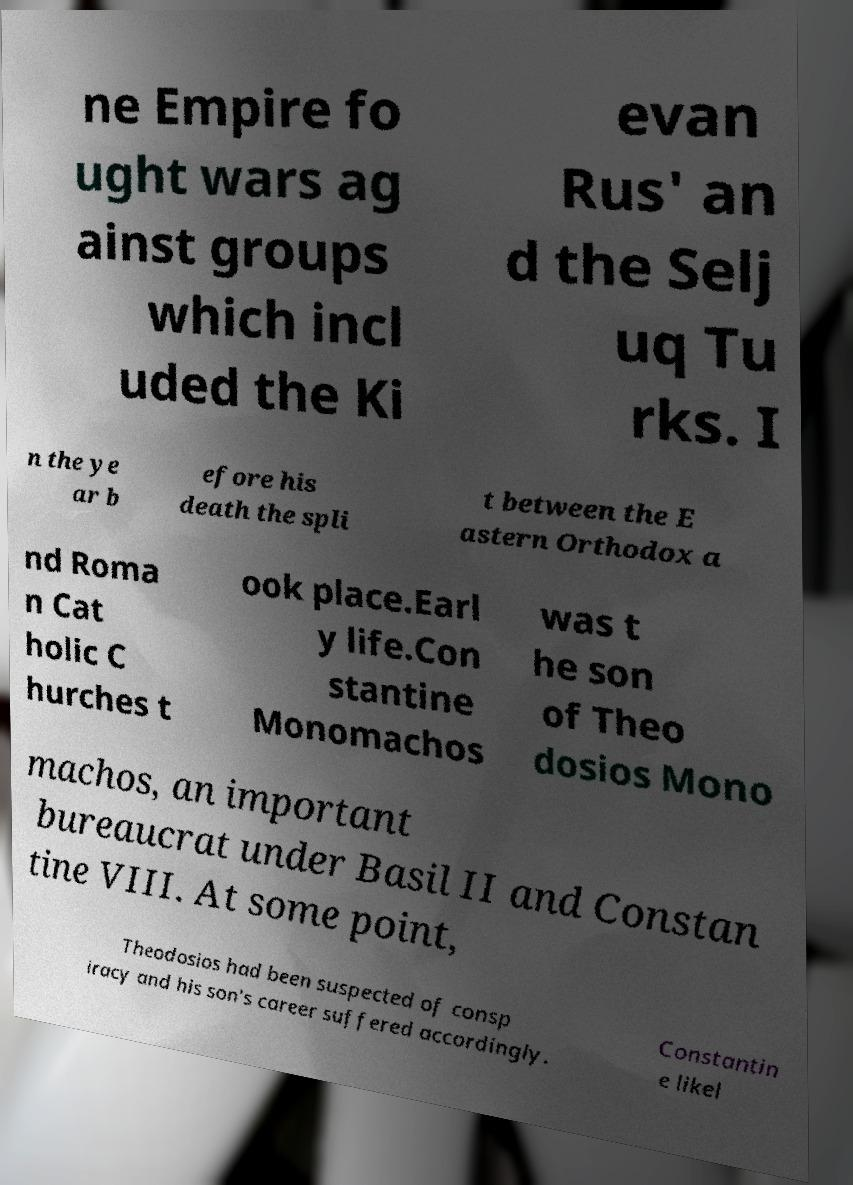What messages or text are displayed in this image? I need them in a readable, typed format. ne Empire fo ught wars ag ainst groups which incl uded the Ki evan Rus' an d the Selj uq Tu rks. I n the ye ar b efore his death the spli t between the E astern Orthodox a nd Roma n Cat holic C hurches t ook place.Earl y life.Con stantine Monomachos was t he son of Theo dosios Mono machos, an important bureaucrat under Basil II and Constan tine VIII. At some point, Theodosios had been suspected of consp iracy and his son's career suffered accordingly. Constantin e likel 